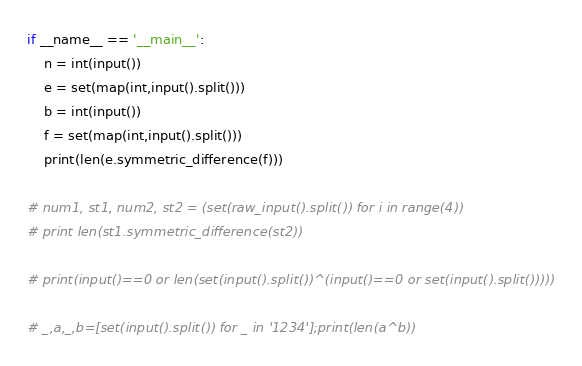Convert code to text. <code><loc_0><loc_0><loc_500><loc_500><_Python_>if __name__ == '__main__':
	n = int(input())
	e = set(map(int,input().split()))
	b = int(input())
	f = set(map(int,input().split()))
	print(len(e.symmetric_difference(f)))

# num1, st1, num2, st2 = (set(raw_input().split()) for i in range(4))
# print len(st1.symmetric_difference(st2))

# print(input()==0 or len(set(input().split())^(input()==0 or set(input().split()))))

# _,a,_,b=[set(input().split()) for _ in '1234'];print(len(a^b))</code> 